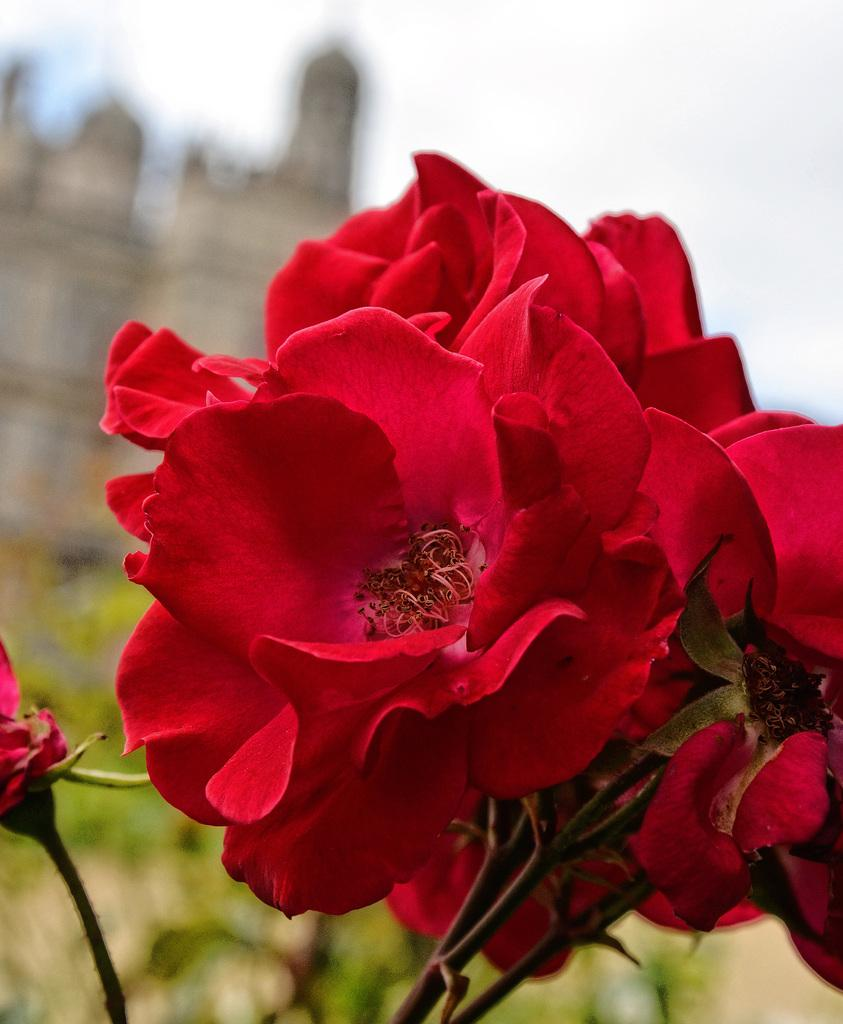What type of flowers are in the foreground of the image? There are red color flowers in the foreground of the image. Can you describe the background of the image? The background of the image is blurred. What type of dirt can be seen in the image? A: There is no dirt visible in the image; it features red color flowers in the foreground and a blurred background. 